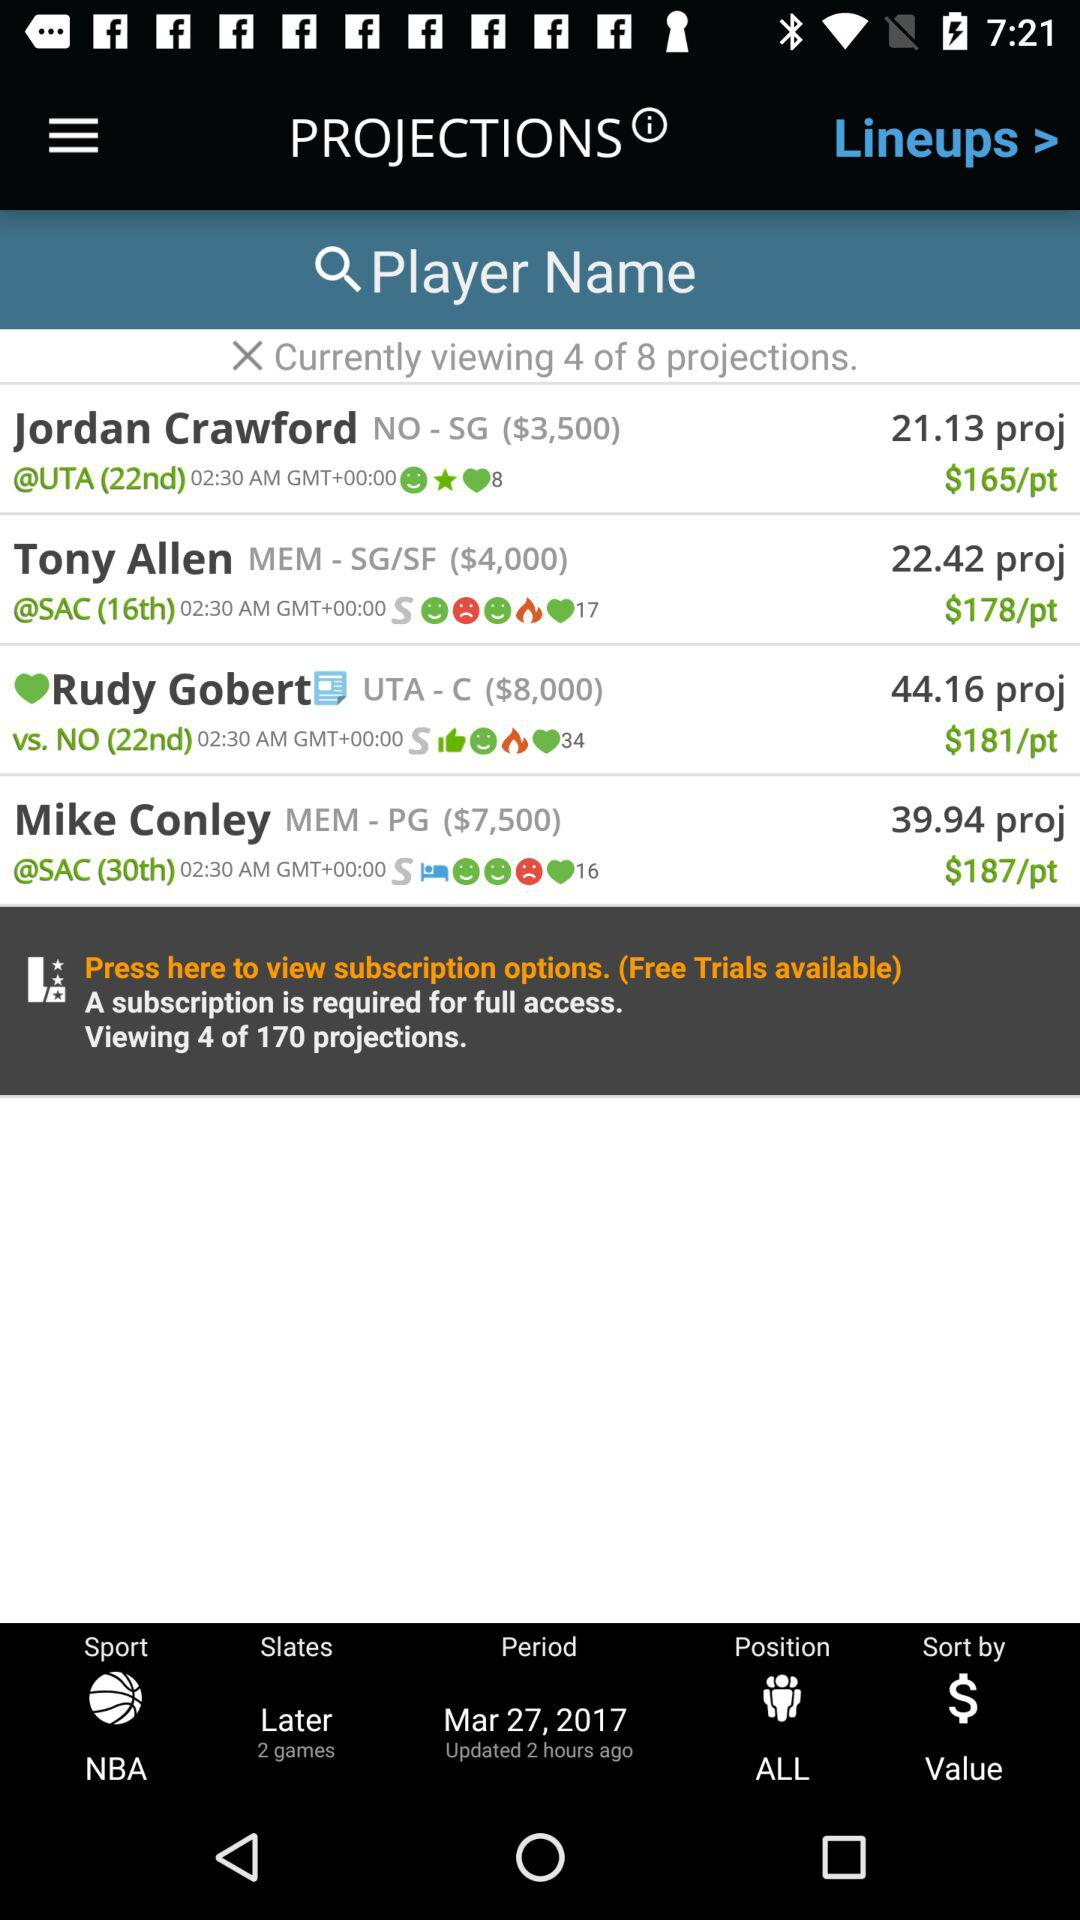Which player has the highest projected score?
Answer the question using a single word or phrase. Rudy Gobert 